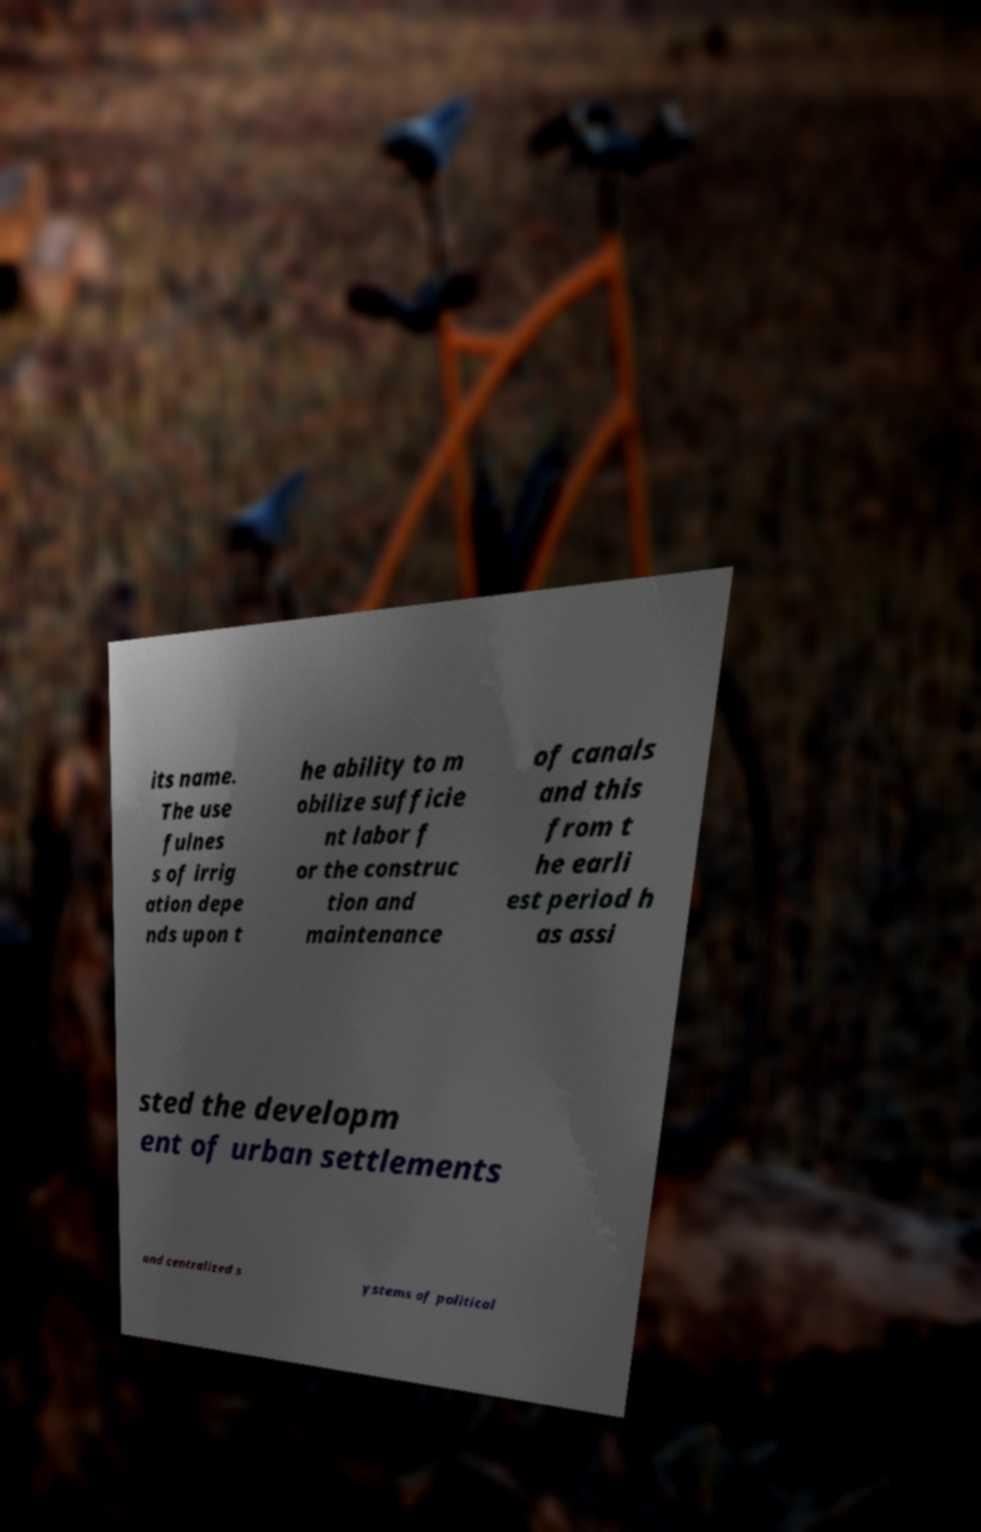There's text embedded in this image that I need extracted. Can you transcribe it verbatim? its name. The use fulnes s of irrig ation depe nds upon t he ability to m obilize sufficie nt labor f or the construc tion and maintenance of canals and this from t he earli est period h as assi sted the developm ent of urban settlements and centralized s ystems of political 